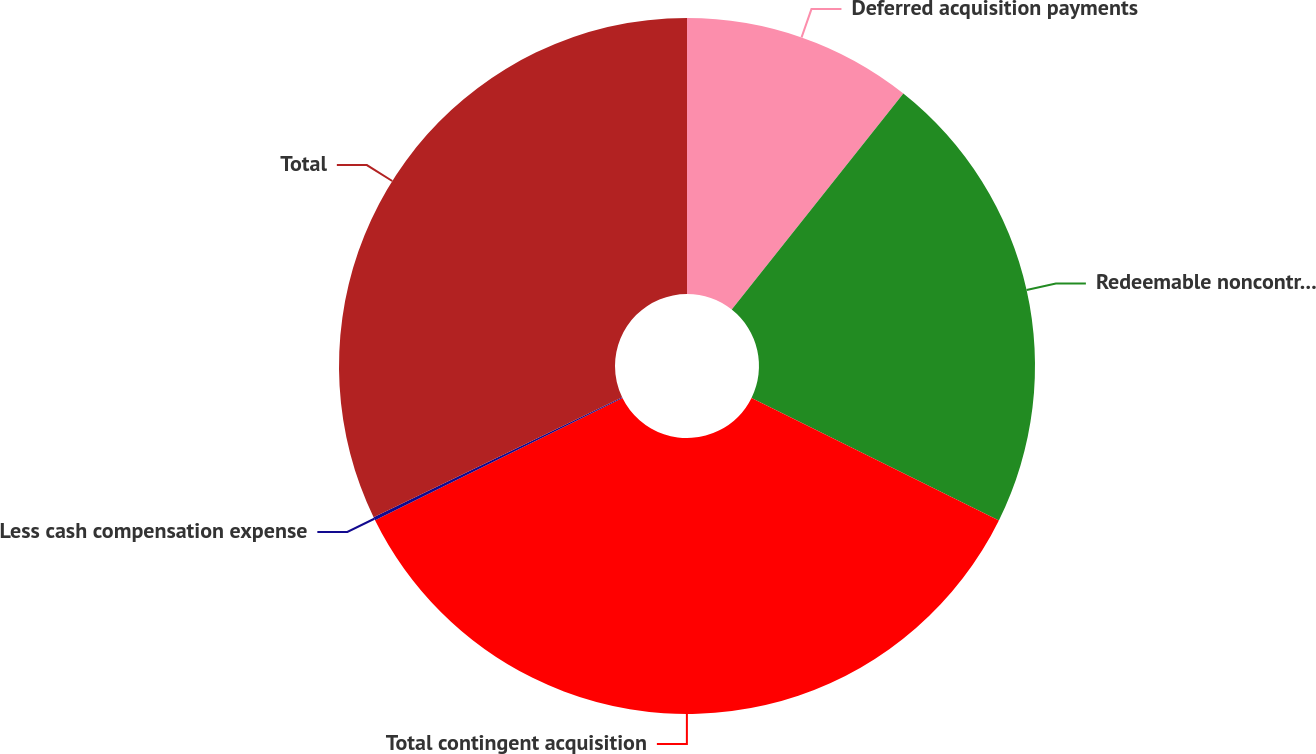<chart> <loc_0><loc_0><loc_500><loc_500><pie_chart><fcel>Deferred acquisition payments<fcel>Redeemable noncontrolling<fcel>Total contingent acquisition<fcel>Less cash compensation expense<fcel>Total<nl><fcel>10.68%<fcel>21.64%<fcel>35.38%<fcel>0.15%<fcel>32.16%<nl></chart> 